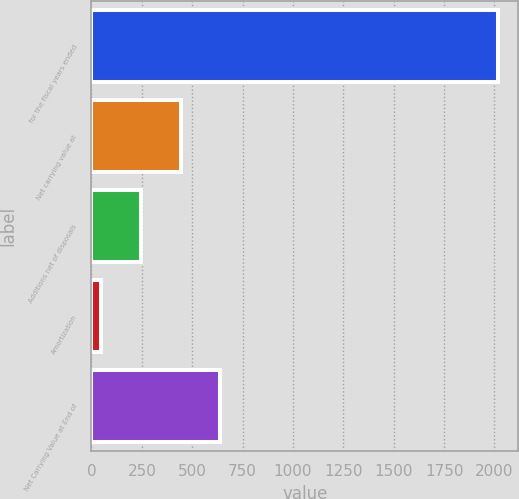<chart> <loc_0><loc_0><loc_500><loc_500><bar_chart><fcel>for the fiscal years ended<fcel>Net carrying value at<fcel>Additions net of disposals<fcel>Amortization<fcel>Net Carrying Value at End of<nl><fcel>2017<fcel>442.68<fcel>245.89<fcel>49.1<fcel>639.47<nl></chart> 